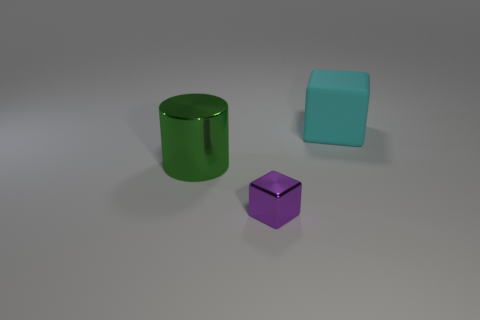What number of big objects are green cylinders or blocks? There are two large objects in the image that match the description: one green cylinder and one block, which is aqua or light blue in color, not green. So, if we are only counting the green objects, there is one large green cylinder. 